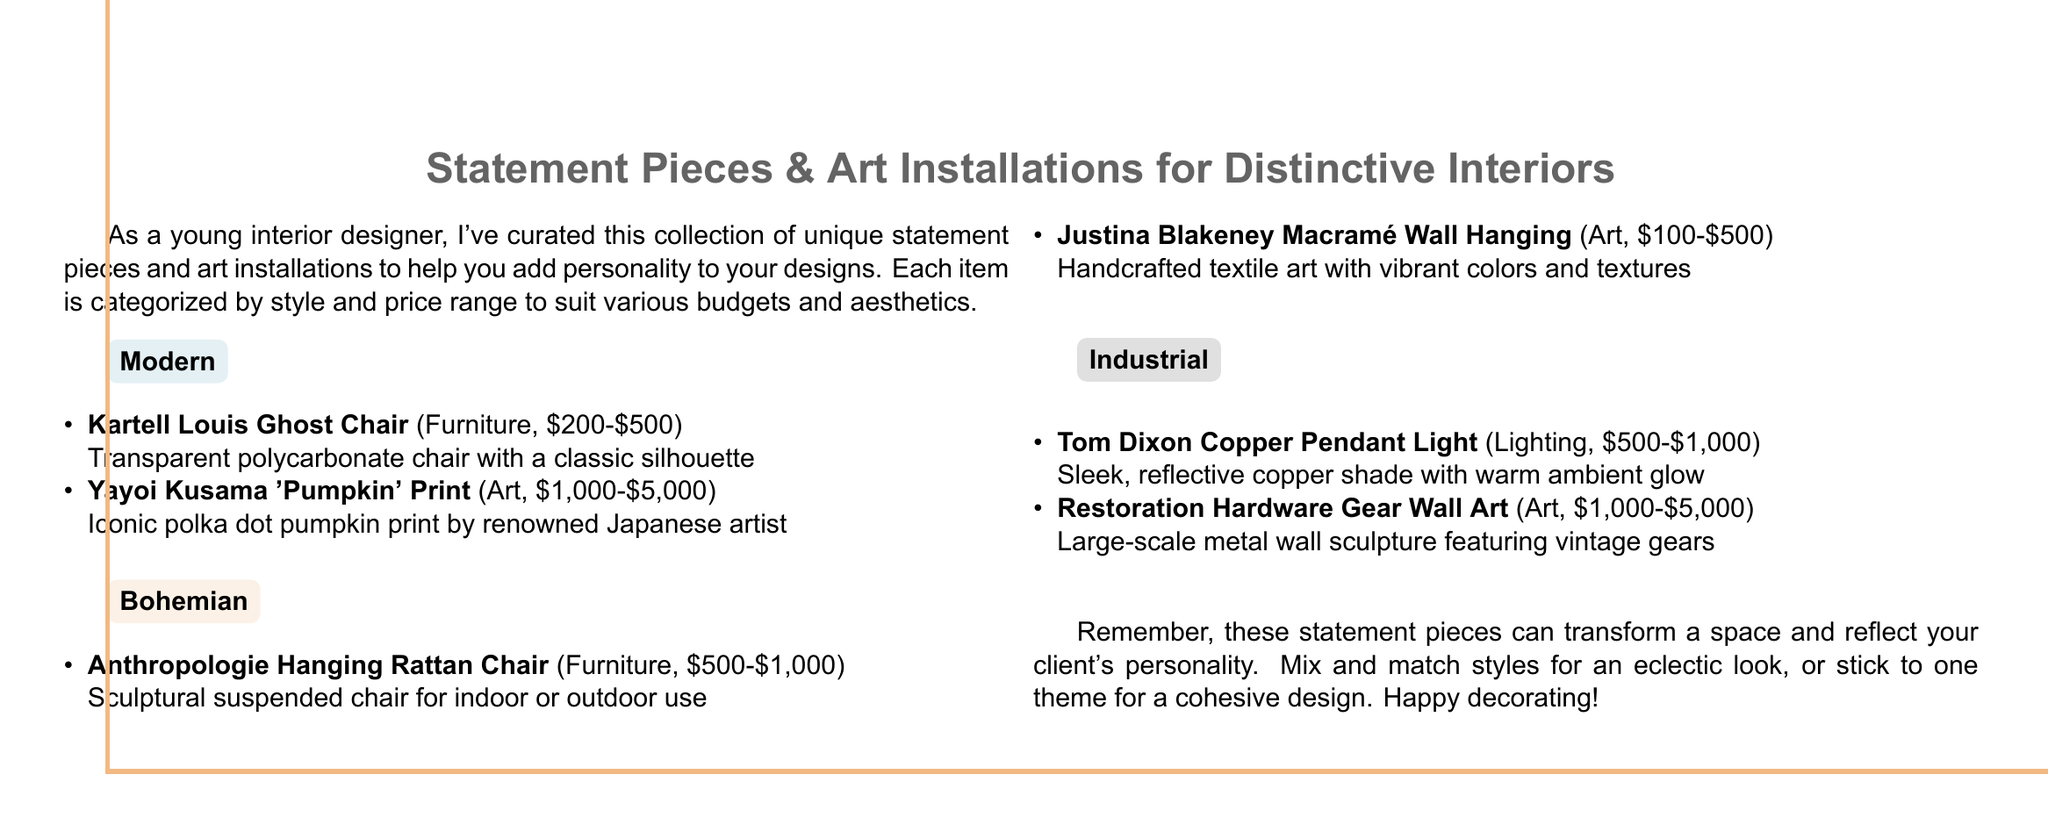What are the two styles featured under the 'Modern' category? The document lists two items under the 'Modern' category, which are a chair and a print.
Answer: Kartell Louis Ghost Chair, Yayoi Kusama 'Pumpkin' Print What is the price range for the 'Justina Blakeney Macramé Wall Hanging'? The price range for this art piece is stated in the document.
Answer: $100-$500 Which two categories of items are included in the catalog? The document explicitly mentions various styles and item categories associated with those styles.
Answer: Modern, Bohemian, Industrial How much does the 'Tom Dixon Copper Pendant Light' cost? The document specifies the price range for this lighting piece.
Answer: $500-$1,000 What is the main purpose of the items listed in the document? The document's introduction highlights that the collection of items is curated for enhancing interior designs.
Answer: Add personality to designs What is the aesthetic style of the 'Anthropologie Hanging Rattan Chair'? The document categorizes items into three styles and identifies this chair's style.
Answer: Bohemian What type of item is the 'Restoration Hardware Gear Wall Art'? The document classifies this item based on its type and style.
Answer: Art 